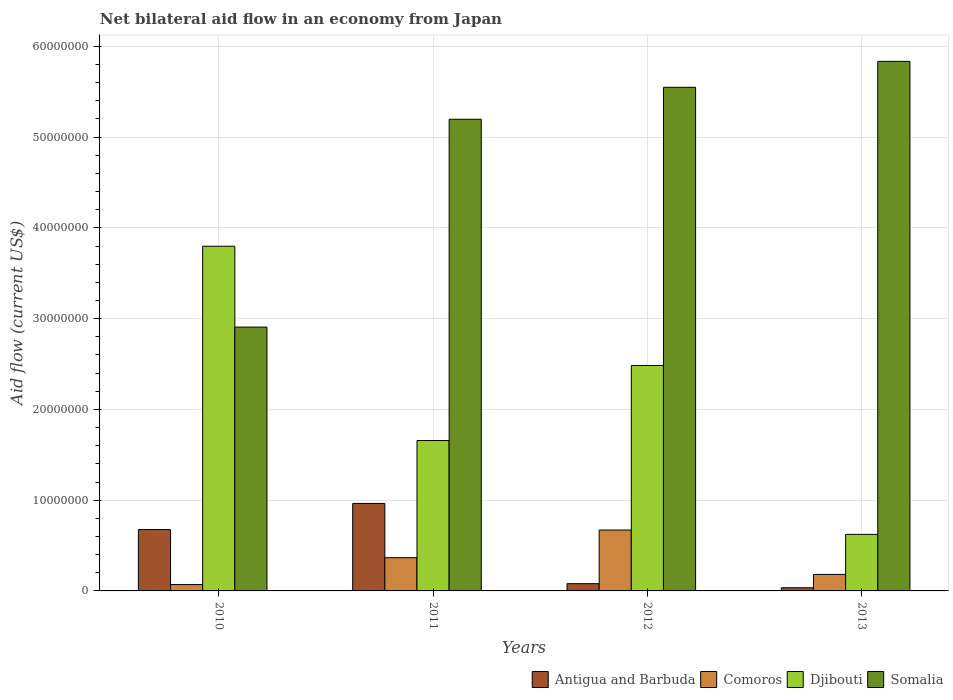How many different coloured bars are there?
Give a very brief answer. 4. How many groups of bars are there?
Offer a very short reply. 4. Are the number of bars per tick equal to the number of legend labels?
Offer a terse response. Yes. What is the net bilateral aid flow in Antigua and Barbuda in 2010?
Your response must be concise. 6.76e+06. Across all years, what is the maximum net bilateral aid flow in Somalia?
Provide a short and direct response. 5.84e+07. In which year was the net bilateral aid flow in Djibouti minimum?
Ensure brevity in your answer.  2013. What is the total net bilateral aid flow in Antigua and Barbuda in the graph?
Your answer should be compact. 1.76e+07. What is the difference between the net bilateral aid flow in Comoros in 2011 and that in 2013?
Offer a very short reply. 1.84e+06. What is the difference between the net bilateral aid flow in Antigua and Barbuda in 2010 and the net bilateral aid flow in Somalia in 2013?
Offer a very short reply. -5.16e+07. What is the average net bilateral aid flow in Comoros per year?
Ensure brevity in your answer.  3.22e+06. In the year 2010, what is the difference between the net bilateral aid flow in Djibouti and net bilateral aid flow in Somalia?
Your answer should be very brief. 8.91e+06. What is the ratio of the net bilateral aid flow in Comoros in 2012 to that in 2013?
Your response must be concise. 3.69. Is the difference between the net bilateral aid flow in Djibouti in 2010 and 2011 greater than the difference between the net bilateral aid flow in Somalia in 2010 and 2011?
Your response must be concise. Yes. What is the difference between the highest and the second highest net bilateral aid flow in Somalia?
Offer a terse response. 2.86e+06. What is the difference between the highest and the lowest net bilateral aid flow in Somalia?
Offer a very short reply. 2.93e+07. Is the sum of the net bilateral aid flow in Comoros in 2010 and 2011 greater than the maximum net bilateral aid flow in Djibouti across all years?
Ensure brevity in your answer.  No. Is it the case that in every year, the sum of the net bilateral aid flow in Somalia and net bilateral aid flow in Antigua and Barbuda is greater than the sum of net bilateral aid flow in Djibouti and net bilateral aid flow in Comoros?
Give a very brief answer. No. What does the 1st bar from the left in 2010 represents?
Your answer should be compact. Antigua and Barbuda. What does the 1st bar from the right in 2010 represents?
Your answer should be compact. Somalia. Is it the case that in every year, the sum of the net bilateral aid flow in Antigua and Barbuda and net bilateral aid flow in Somalia is greater than the net bilateral aid flow in Djibouti?
Your answer should be compact. No. How many bars are there?
Provide a short and direct response. 16. Are all the bars in the graph horizontal?
Offer a terse response. No. How many years are there in the graph?
Keep it short and to the point. 4. How many legend labels are there?
Offer a terse response. 4. How are the legend labels stacked?
Provide a succinct answer. Horizontal. What is the title of the graph?
Make the answer very short. Net bilateral aid flow in an economy from Japan. What is the label or title of the X-axis?
Provide a succinct answer. Years. What is the Aid flow (current US$) in Antigua and Barbuda in 2010?
Your answer should be compact. 6.76e+06. What is the Aid flow (current US$) in Comoros in 2010?
Ensure brevity in your answer.  7.00e+05. What is the Aid flow (current US$) of Djibouti in 2010?
Give a very brief answer. 3.80e+07. What is the Aid flow (current US$) of Somalia in 2010?
Keep it short and to the point. 2.91e+07. What is the Aid flow (current US$) in Antigua and Barbuda in 2011?
Your response must be concise. 9.64e+06. What is the Aid flow (current US$) of Comoros in 2011?
Make the answer very short. 3.66e+06. What is the Aid flow (current US$) in Djibouti in 2011?
Provide a succinct answer. 1.66e+07. What is the Aid flow (current US$) of Somalia in 2011?
Your answer should be very brief. 5.20e+07. What is the Aid flow (current US$) in Antigua and Barbuda in 2012?
Your response must be concise. 8.00e+05. What is the Aid flow (current US$) of Comoros in 2012?
Your answer should be compact. 6.71e+06. What is the Aid flow (current US$) of Djibouti in 2012?
Ensure brevity in your answer.  2.48e+07. What is the Aid flow (current US$) in Somalia in 2012?
Your answer should be compact. 5.55e+07. What is the Aid flow (current US$) in Antigua and Barbuda in 2013?
Provide a succinct answer. 3.50e+05. What is the Aid flow (current US$) of Comoros in 2013?
Give a very brief answer. 1.82e+06. What is the Aid flow (current US$) of Djibouti in 2013?
Ensure brevity in your answer.  6.23e+06. What is the Aid flow (current US$) in Somalia in 2013?
Offer a terse response. 5.84e+07. Across all years, what is the maximum Aid flow (current US$) in Antigua and Barbuda?
Give a very brief answer. 9.64e+06. Across all years, what is the maximum Aid flow (current US$) of Comoros?
Provide a short and direct response. 6.71e+06. Across all years, what is the maximum Aid flow (current US$) of Djibouti?
Provide a short and direct response. 3.80e+07. Across all years, what is the maximum Aid flow (current US$) in Somalia?
Provide a short and direct response. 5.84e+07. Across all years, what is the minimum Aid flow (current US$) of Djibouti?
Make the answer very short. 6.23e+06. Across all years, what is the minimum Aid flow (current US$) in Somalia?
Your answer should be compact. 2.91e+07. What is the total Aid flow (current US$) in Antigua and Barbuda in the graph?
Offer a very short reply. 1.76e+07. What is the total Aid flow (current US$) of Comoros in the graph?
Offer a very short reply. 1.29e+07. What is the total Aid flow (current US$) of Djibouti in the graph?
Keep it short and to the point. 8.56e+07. What is the total Aid flow (current US$) in Somalia in the graph?
Keep it short and to the point. 1.95e+08. What is the difference between the Aid flow (current US$) of Antigua and Barbuda in 2010 and that in 2011?
Provide a short and direct response. -2.88e+06. What is the difference between the Aid flow (current US$) of Comoros in 2010 and that in 2011?
Make the answer very short. -2.96e+06. What is the difference between the Aid flow (current US$) of Djibouti in 2010 and that in 2011?
Give a very brief answer. 2.14e+07. What is the difference between the Aid flow (current US$) of Somalia in 2010 and that in 2011?
Give a very brief answer. -2.29e+07. What is the difference between the Aid flow (current US$) in Antigua and Barbuda in 2010 and that in 2012?
Your response must be concise. 5.96e+06. What is the difference between the Aid flow (current US$) of Comoros in 2010 and that in 2012?
Provide a short and direct response. -6.01e+06. What is the difference between the Aid flow (current US$) of Djibouti in 2010 and that in 2012?
Offer a very short reply. 1.31e+07. What is the difference between the Aid flow (current US$) in Somalia in 2010 and that in 2012?
Provide a succinct answer. -2.64e+07. What is the difference between the Aid flow (current US$) in Antigua and Barbuda in 2010 and that in 2013?
Your response must be concise. 6.41e+06. What is the difference between the Aid flow (current US$) of Comoros in 2010 and that in 2013?
Make the answer very short. -1.12e+06. What is the difference between the Aid flow (current US$) of Djibouti in 2010 and that in 2013?
Your answer should be very brief. 3.18e+07. What is the difference between the Aid flow (current US$) in Somalia in 2010 and that in 2013?
Ensure brevity in your answer.  -2.93e+07. What is the difference between the Aid flow (current US$) in Antigua and Barbuda in 2011 and that in 2012?
Ensure brevity in your answer.  8.84e+06. What is the difference between the Aid flow (current US$) in Comoros in 2011 and that in 2012?
Provide a short and direct response. -3.05e+06. What is the difference between the Aid flow (current US$) of Djibouti in 2011 and that in 2012?
Your answer should be very brief. -8.27e+06. What is the difference between the Aid flow (current US$) of Somalia in 2011 and that in 2012?
Your answer should be very brief. -3.52e+06. What is the difference between the Aid flow (current US$) of Antigua and Barbuda in 2011 and that in 2013?
Provide a succinct answer. 9.29e+06. What is the difference between the Aid flow (current US$) in Comoros in 2011 and that in 2013?
Make the answer very short. 1.84e+06. What is the difference between the Aid flow (current US$) of Djibouti in 2011 and that in 2013?
Provide a succinct answer. 1.03e+07. What is the difference between the Aid flow (current US$) in Somalia in 2011 and that in 2013?
Your answer should be very brief. -6.38e+06. What is the difference between the Aid flow (current US$) of Comoros in 2012 and that in 2013?
Ensure brevity in your answer.  4.89e+06. What is the difference between the Aid flow (current US$) of Djibouti in 2012 and that in 2013?
Provide a short and direct response. 1.86e+07. What is the difference between the Aid flow (current US$) in Somalia in 2012 and that in 2013?
Offer a terse response. -2.86e+06. What is the difference between the Aid flow (current US$) in Antigua and Barbuda in 2010 and the Aid flow (current US$) in Comoros in 2011?
Ensure brevity in your answer.  3.10e+06. What is the difference between the Aid flow (current US$) in Antigua and Barbuda in 2010 and the Aid flow (current US$) in Djibouti in 2011?
Offer a terse response. -9.81e+06. What is the difference between the Aid flow (current US$) of Antigua and Barbuda in 2010 and the Aid flow (current US$) of Somalia in 2011?
Your answer should be compact. -4.52e+07. What is the difference between the Aid flow (current US$) in Comoros in 2010 and the Aid flow (current US$) in Djibouti in 2011?
Your answer should be compact. -1.59e+07. What is the difference between the Aid flow (current US$) in Comoros in 2010 and the Aid flow (current US$) in Somalia in 2011?
Provide a succinct answer. -5.13e+07. What is the difference between the Aid flow (current US$) in Djibouti in 2010 and the Aid flow (current US$) in Somalia in 2011?
Provide a succinct answer. -1.40e+07. What is the difference between the Aid flow (current US$) of Antigua and Barbuda in 2010 and the Aid flow (current US$) of Djibouti in 2012?
Your answer should be very brief. -1.81e+07. What is the difference between the Aid flow (current US$) in Antigua and Barbuda in 2010 and the Aid flow (current US$) in Somalia in 2012?
Keep it short and to the point. -4.87e+07. What is the difference between the Aid flow (current US$) of Comoros in 2010 and the Aid flow (current US$) of Djibouti in 2012?
Offer a terse response. -2.41e+07. What is the difference between the Aid flow (current US$) in Comoros in 2010 and the Aid flow (current US$) in Somalia in 2012?
Keep it short and to the point. -5.48e+07. What is the difference between the Aid flow (current US$) of Djibouti in 2010 and the Aid flow (current US$) of Somalia in 2012?
Offer a very short reply. -1.75e+07. What is the difference between the Aid flow (current US$) in Antigua and Barbuda in 2010 and the Aid flow (current US$) in Comoros in 2013?
Provide a short and direct response. 4.94e+06. What is the difference between the Aid flow (current US$) in Antigua and Barbuda in 2010 and the Aid flow (current US$) in Djibouti in 2013?
Keep it short and to the point. 5.30e+05. What is the difference between the Aid flow (current US$) in Antigua and Barbuda in 2010 and the Aid flow (current US$) in Somalia in 2013?
Offer a very short reply. -5.16e+07. What is the difference between the Aid flow (current US$) of Comoros in 2010 and the Aid flow (current US$) of Djibouti in 2013?
Your response must be concise. -5.53e+06. What is the difference between the Aid flow (current US$) of Comoros in 2010 and the Aid flow (current US$) of Somalia in 2013?
Offer a terse response. -5.76e+07. What is the difference between the Aid flow (current US$) of Djibouti in 2010 and the Aid flow (current US$) of Somalia in 2013?
Offer a terse response. -2.04e+07. What is the difference between the Aid flow (current US$) of Antigua and Barbuda in 2011 and the Aid flow (current US$) of Comoros in 2012?
Provide a short and direct response. 2.93e+06. What is the difference between the Aid flow (current US$) in Antigua and Barbuda in 2011 and the Aid flow (current US$) in Djibouti in 2012?
Give a very brief answer. -1.52e+07. What is the difference between the Aid flow (current US$) of Antigua and Barbuda in 2011 and the Aid flow (current US$) of Somalia in 2012?
Provide a short and direct response. -4.58e+07. What is the difference between the Aid flow (current US$) in Comoros in 2011 and the Aid flow (current US$) in Djibouti in 2012?
Your answer should be very brief. -2.12e+07. What is the difference between the Aid flow (current US$) in Comoros in 2011 and the Aid flow (current US$) in Somalia in 2012?
Provide a short and direct response. -5.18e+07. What is the difference between the Aid flow (current US$) in Djibouti in 2011 and the Aid flow (current US$) in Somalia in 2012?
Give a very brief answer. -3.89e+07. What is the difference between the Aid flow (current US$) of Antigua and Barbuda in 2011 and the Aid flow (current US$) of Comoros in 2013?
Your response must be concise. 7.82e+06. What is the difference between the Aid flow (current US$) in Antigua and Barbuda in 2011 and the Aid flow (current US$) in Djibouti in 2013?
Ensure brevity in your answer.  3.41e+06. What is the difference between the Aid flow (current US$) in Antigua and Barbuda in 2011 and the Aid flow (current US$) in Somalia in 2013?
Give a very brief answer. -4.87e+07. What is the difference between the Aid flow (current US$) in Comoros in 2011 and the Aid flow (current US$) in Djibouti in 2013?
Keep it short and to the point. -2.57e+06. What is the difference between the Aid flow (current US$) in Comoros in 2011 and the Aid flow (current US$) in Somalia in 2013?
Your answer should be very brief. -5.47e+07. What is the difference between the Aid flow (current US$) in Djibouti in 2011 and the Aid flow (current US$) in Somalia in 2013?
Keep it short and to the point. -4.18e+07. What is the difference between the Aid flow (current US$) of Antigua and Barbuda in 2012 and the Aid flow (current US$) of Comoros in 2013?
Make the answer very short. -1.02e+06. What is the difference between the Aid flow (current US$) of Antigua and Barbuda in 2012 and the Aid flow (current US$) of Djibouti in 2013?
Your answer should be very brief. -5.43e+06. What is the difference between the Aid flow (current US$) in Antigua and Barbuda in 2012 and the Aid flow (current US$) in Somalia in 2013?
Your answer should be very brief. -5.76e+07. What is the difference between the Aid flow (current US$) in Comoros in 2012 and the Aid flow (current US$) in Somalia in 2013?
Provide a succinct answer. -5.16e+07. What is the difference between the Aid flow (current US$) of Djibouti in 2012 and the Aid flow (current US$) of Somalia in 2013?
Offer a very short reply. -3.35e+07. What is the average Aid flow (current US$) of Antigua and Barbuda per year?
Your response must be concise. 4.39e+06. What is the average Aid flow (current US$) in Comoros per year?
Offer a very short reply. 3.22e+06. What is the average Aid flow (current US$) in Djibouti per year?
Provide a short and direct response. 2.14e+07. What is the average Aid flow (current US$) of Somalia per year?
Your answer should be compact. 4.87e+07. In the year 2010, what is the difference between the Aid flow (current US$) of Antigua and Barbuda and Aid flow (current US$) of Comoros?
Offer a very short reply. 6.06e+06. In the year 2010, what is the difference between the Aid flow (current US$) of Antigua and Barbuda and Aid flow (current US$) of Djibouti?
Your answer should be very brief. -3.12e+07. In the year 2010, what is the difference between the Aid flow (current US$) in Antigua and Barbuda and Aid flow (current US$) in Somalia?
Provide a succinct answer. -2.23e+07. In the year 2010, what is the difference between the Aid flow (current US$) in Comoros and Aid flow (current US$) in Djibouti?
Give a very brief answer. -3.73e+07. In the year 2010, what is the difference between the Aid flow (current US$) in Comoros and Aid flow (current US$) in Somalia?
Your answer should be very brief. -2.84e+07. In the year 2010, what is the difference between the Aid flow (current US$) in Djibouti and Aid flow (current US$) in Somalia?
Keep it short and to the point. 8.91e+06. In the year 2011, what is the difference between the Aid flow (current US$) of Antigua and Barbuda and Aid flow (current US$) of Comoros?
Your answer should be compact. 5.98e+06. In the year 2011, what is the difference between the Aid flow (current US$) in Antigua and Barbuda and Aid flow (current US$) in Djibouti?
Your answer should be very brief. -6.93e+06. In the year 2011, what is the difference between the Aid flow (current US$) of Antigua and Barbuda and Aid flow (current US$) of Somalia?
Your answer should be very brief. -4.23e+07. In the year 2011, what is the difference between the Aid flow (current US$) in Comoros and Aid flow (current US$) in Djibouti?
Ensure brevity in your answer.  -1.29e+07. In the year 2011, what is the difference between the Aid flow (current US$) of Comoros and Aid flow (current US$) of Somalia?
Offer a terse response. -4.83e+07. In the year 2011, what is the difference between the Aid flow (current US$) in Djibouti and Aid flow (current US$) in Somalia?
Offer a very short reply. -3.54e+07. In the year 2012, what is the difference between the Aid flow (current US$) in Antigua and Barbuda and Aid flow (current US$) in Comoros?
Provide a short and direct response. -5.91e+06. In the year 2012, what is the difference between the Aid flow (current US$) of Antigua and Barbuda and Aid flow (current US$) of Djibouti?
Give a very brief answer. -2.40e+07. In the year 2012, what is the difference between the Aid flow (current US$) of Antigua and Barbuda and Aid flow (current US$) of Somalia?
Keep it short and to the point. -5.47e+07. In the year 2012, what is the difference between the Aid flow (current US$) of Comoros and Aid flow (current US$) of Djibouti?
Offer a very short reply. -1.81e+07. In the year 2012, what is the difference between the Aid flow (current US$) of Comoros and Aid flow (current US$) of Somalia?
Offer a terse response. -4.88e+07. In the year 2012, what is the difference between the Aid flow (current US$) of Djibouti and Aid flow (current US$) of Somalia?
Give a very brief answer. -3.06e+07. In the year 2013, what is the difference between the Aid flow (current US$) of Antigua and Barbuda and Aid flow (current US$) of Comoros?
Offer a terse response. -1.47e+06. In the year 2013, what is the difference between the Aid flow (current US$) in Antigua and Barbuda and Aid flow (current US$) in Djibouti?
Provide a succinct answer. -5.88e+06. In the year 2013, what is the difference between the Aid flow (current US$) of Antigua and Barbuda and Aid flow (current US$) of Somalia?
Offer a terse response. -5.80e+07. In the year 2013, what is the difference between the Aid flow (current US$) of Comoros and Aid flow (current US$) of Djibouti?
Your answer should be compact. -4.41e+06. In the year 2013, what is the difference between the Aid flow (current US$) in Comoros and Aid flow (current US$) in Somalia?
Make the answer very short. -5.65e+07. In the year 2013, what is the difference between the Aid flow (current US$) in Djibouti and Aid flow (current US$) in Somalia?
Ensure brevity in your answer.  -5.21e+07. What is the ratio of the Aid flow (current US$) of Antigua and Barbuda in 2010 to that in 2011?
Offer a very short reply. 0.7. What is the ratio of the Aid flow (current US$) of Comoros in 2010 to that in 2011?
Offer a terse response. 0.19. What is the ratio of the Aid flow (current US$) in Djibouti in 2010 to that in 2011?
Offer a very short reply. 2.29. What is the ratio of the Aid flow (current US$) of Somalia in 2010 to that in 2011?
Your answer should be compact. 0.56. What is the ratio of the Aid flow (current US$) in Antigua and Barbuda in 2010 to that in 2012?
Keep it short and to the point. 8.45. What is the ratio of the Aid flow (current US$) of Comoros in 2010 to that in 2012?
Your answer should be very brief. 0.1. What is the ratio of the Aid flow (current US$) in Djibouti in 2010 to that in 2012?
Make the answer very short. 1.53. What is the ratio of the Aid flow (current US$) of Somalia in 2010 to that in 2012?
Offer a very short reply. 0.52. What is the ratio of the Aid flow (current US$) in Antigua and Barbuda in 2010 to that in 2013?
Offer a terse response. 19.31. What is the ratio of the Aid flow (current US$) in Comoros in 2010 to that in 2013?
Your answer should be very brief. 0.38. What is the ratio of the Aid flow (current US$) of Djibouti in 2010 to that in 2013?
Your answer should be very brief. 6.1. What is the ratio of the Aid flow (current US$) of Somalia in 2010 to that in 2013?
Offer a very short reply. 0.5. What is the ratio of the Aid flow (current US$) in Antigua and Barbuda in 2011 to that in 2012?
Offer a terse response. 12.05. What is the ratio of the Aid flow (current US$) in Comoros in 2011 to that in 2012?
Offer a very short reply. 0.55. What is the ratio of the Aid flow (current US$) in Djibouti in 2011 to that in 2012?
Give a very brief answer. 0.67. What is the ratio of the Aid flow (current US$) in Somalia in 2011 to that in 2012?
Your answer should be compact. 0.94. What is the ratio of the Aid flow (current US$) in Antigua and Barbuda in 2011 to that in 2013?
Offer a terse response. 27.54. What is the ratio of the Aid flow (current US$) of Comoros in 2011 to that in 2013?
Provide a short and direct response. 2.01. What is the ratio of the Aid flow (current US$) in Djibouti in 2011 to that in 2013?
Your response must be concise. 2.66. What is the ratio of the Aid flow (current US$) in Somalia in 2011 to that in 2013?
Give a very brief answer. 0.89. What is the ratio of the Aid flow (current US$) in Antigua and Barbuda in 2012 to that in 2013?
Offer a very short reply. 2.29. What is the ratio of the Aid flow (current US$) in Comoros in 2012 to that in 2013?
Provide a succinct answer. 3.69. What is the ratio of the Aid flow (current US$) in Djibouti in 2012 to that in 2013?
Ensure brevity in your answer.  3.99. What is the ratio of the Aid flow (current US$) in Somalia in 2012 to that in 2013?
Provide a short and direct response. 0.95. What is the difference between the highest and the second highest Aid flow (current US$) in Antigua and Barbuda?
Your response must be concise. 2.88e+06. What is the difference between the highest and the second highest Aid flow (current US$) of Comoros?
Keep it short and to the point. 3.05e+06. What is the difference between the highest and the second highest Aid flow (current US$) of Djibouti?
Provide a short and direct response. 1.31e+07. What is the difference between the highest and the second highest Aid flow (current US$) of Somalia?
Your answer should be very brief. 2.86e+06. What is the difference between the highest and the lowest Aid flow (current US$) of Antigua and Barbuda?
Your response must be concise. 9.29e+06. What is the difference between the highest and the lowest Aid flow (current US$) in Comoros?
Give a very brief answer. 6.01e+06. What is the difference between the highest and the lowest Aid flow (current US$) in Djibouti?
Make the answer very short. 3.18e+07. What is the difference between the highest and the lowest Aid flow (current US$) in Somalia?
Make the answer very short. 2.93e+07. 